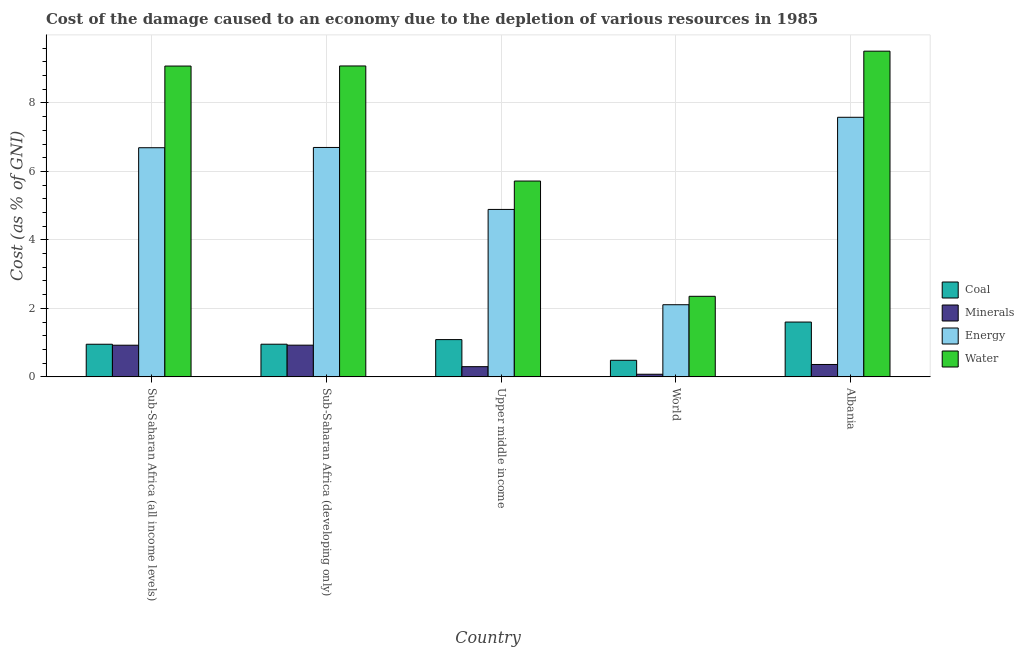What is the label of the 5th group of bars from the left?
Make the answer very short. Albania. In how many cases, is the number of bars for a given country not equal to the number of legend labels?
Ensure brevity in your answer.  0. What is the cost of damage due to depletion of coal in Albania?
Give a very brief answer. 1.6. Across all countries, what is the maximum cost of damage due to depletion of water?
Offer a terse response. 9.51. Across all countries, what is the minimum cost of damage due to depletion of energy?
Provide a succinct answer. 2.11. In which country was the cost of damage due to depletion of water maximum?
Your response must be concise. Albania. What is the total cost of damage due to depletion of energy in the graph?
Provide a succinct answer. 27.97. What is the difference between the cost of damage due to depletion of coal in Sub-Saharan Africa (all income levels) and that in Sub-Saharan Africa (developing only)?
Offer a terse response. -0. What is the difference between the cost of damage due to depletion of coal in Sub-Saharan Africa (developing only) and the cost of damage due to depletion of energy in World?
Provide a succinct answer. -1.15. What is the average cost of damage due to depletion of coal per country?
Provide a short and direct response. 1.02. What is the difference between the cost of damage due to depletion of coal and cost of damage due to depletion of minerals in Sub-Saharan Africa (developing only)?
Your answer should be very brief. 0.03. What is the ratio of the cost of damage due to depletion of coal in Sub-Saharan Africa (all income levels) to that in World?
Offer a very short reply. 1.97. Is the difference between the cost of damage due to depletion of energy in Sub-Saharan Africa (developing only) and Upper middle income greater than the difference between the cost of damage due to depletion of minerals in Sub-Saharan Africa (developing only) and Upper middle income?
Your answer should be compact. Yes. What is the difference between the highest and the second highest cost of damage due to depletion of energy?
Provide a succinct answer. 0.88. What is the difference between the highest and the lowest cost of damage due to depletion of water?
Provide a succinct answer. 7.16. Is the sum of the cost of damage due to depletion of water in Albania and Sub-Saharan Africa (developing only) greater than the maximum cost of damage due to depletion of energy across all countries?
Ensure brevity in your answer.  Yes. Is it the case that in every country, the sum of the cost of damage due to depletion of coal and cost of damage due to depletion of water is greater than the sum of cost of damage due to depletion of energy and cost of damage due to depletion of minerals?
Ensure brevity in your answer.  Yes. What does the 3rd bar from the left in Upper middle income represents?
Keep it short and to the point. Energy. What does the 3rd bar from the right in Albania represents?
Offer a terse response. Minerals. Are all the bars in the graph horizontal?
Provide a short and direct response. No. How many countries are there in the graph?
Ensure brevity in your answer.  5. Does the graph contain any zero values?
Offer a very short reply. No. How many legend labels are there?
Make the answer very short. 4. How are the legend labels stacked?
Provide a short and direct response. Vertical. What is the title of the graph?
Your answer should be very brief. Cost of the damage caused to an economy due to the depletion of various resources in 1985 . Does "Water" appear as one of the legend labels in the graph?
Provide a short and direct response. Yes. What is the label or title of the Y-axis?
Give a very brief answer. Cost (as % of GNI). What is the Cost (as % of GNI) in Coal in Sub-Saharan Africa (all income levels)?
Keep it short and to the point. 0.95. What is the Cost (as % of GNI) in Minerals in Sub-Saharan Africa (all income levels)?
Offer a very short reply. 0.92. What is the Cost (as % of GNI) in Energy in Sub-Saharan Africa (all income levels)?
Make the answer very short. 6.69. What is the Cost (as % of GNI) in Water in Sub-Saharan Africa (all income levels)?
Make the answer very short. 9.08. What is the Cost (as % of GNI) in Coal in Sub-Saharan Africa (developing only)?
Provide a short and direct response. 0.95. What is the Cost (as % of GNI) in Minerals in Sub-Saharan Africa (developing only)?
Provide a succinct answer. 0.93. What is the Cost (as % of GNI) of Energy in Sub-Saharan Africa (developing only)?
Make the answer very short. 6.7. What is the Cost (as % of GNI) in Water in Sub-Saharan Africa (developing only)?
Provide a short and direct response. 9.08. What is the Cost (as % of GNI) of Coal in Upper middle income?
Your answer should be very brief. 1.09. What is the Cost (as % of GNI) of Minerals in Upper middle income?
Give a very brief answer. 0.3. What is the Cost (as % of GNI) of Energy in Upper middle income?
Keep it short and to the point. 4.89. What is the Cost (as % of GNI) in Water in Upper middle income?
Provide a succinct answer. 5.72. What is the Cost (as % of GNI) in Coal in World?
Provide a succinct answer. 0.48. What is the Cost (as % of GNI) of Minerals in World?
Make the answer very short. 0.08. What is the Cost (as % of GNI) in Energy in World?
Offer a very short reply. 2.11. What is the Cost (as % of GNI) of Water in World?
Make the answer very short. 2.35. What is the Cost (as % of GNI) in Coal in Albania?
Keep it short and to the point. 1.6. What is the Cost (as % of GNI) of Minerals in Albania?
Offer a very short reply. 0.36. What is the Cost (as % of GNI) in Energy in Albania?
Your answer should be very brief. 7.58. What is the Cost (as % of GNI) of Water in Albania?
Your answer should be very brief. 9.51. Across all countries, what is the maximum Cost (as % of GNI) in Coal?
Give a very brief answer. 1.6. Across all countries, what is the maximum Cost (as % of GNI) of Minerals?
Offer a very short reply. 0.93. Across all countries, what is the maximum Cost (as % of GNI) of Energy?
Provide a short and direct response. 7.58. Across all countries, what is the maximum Cost (as % of GNI) of Water?
Give a very brief answer. 9.51. Across all countries, what is the minimum Cost (as % of GNI) of Coal?
Give a very brief answer. 0.48. Across all countries, what is the minimum Cost (as % of GNI) of Minerals?
Your answer should be very brief. 0.08. Across all countries, what is the minimum Cost (as % of GNI) of Energy?
Keep it short and to the point. 2.11. Across all countries, what is the minimum Cost (as % of GNI) in Water?
Keep it short and to the point. 2.35. What is the total Cost (as % of GNI) of Coal in the graph?
Your answer should be compact. 5.08. What is the total Cost (as % of GNI) of Minerals in the graph?
Ensure brevity in your answer.  2.59. What is the total Cost (as % of GNI) of Energy in the graph?
Give a very brief answer. 27.97. What is the total Cost (as % of GNI) in Water in the graph?
Offer a very short reply. 35.74. What is the difference between the Cost (as % of GNI) in Coal in Sub-Saharan Africa (all income levels) and that in Sub-Saharan Africa (developing only)?
Offer a terse response. -0. What is the difference between the Cost (as % of GNI) of Minerals in Sub-Saharan Africa (all income levels) and that in Sub-Saharan Africa (developing only)?
Offer a very short reply. -0. What is the difference between the Cost (as % of GNI) in Energy in Sub-Saharan Africa (all income levels) and that in Sub-Saharan Africa (developing only)?
Provide a succinct answer. -0.01. What is the difference between the Cost (as % of GNI) of Water in Sub-Saharan Africa (all income levels) and that in Sub-Saharan Africa (developing only)?
Your response must be concise. -0. What is the difference between the Cost (as % of GNI) of Coal in Sub-Saharan Africa (all income levels) and that in Upper middle income?
Ensure brevity in your answer.  -0.14. What is the difference between the Cost (as % of GNI) of Minerals in Sub-Saharan Africa (all income levels) and that in Upper middle income?
Give a very brief answer. 0.63. What is the difference between the Cost (as % of GNI) of Energy in Sub-Saharan Africa (all income levels) and that in Upper middle income?
Offer a very short reply. 1.8. What is the difference between the Cost (as % of GNI) in Water in Sub-Saharan Africa (all income levels) and that in Upper middle income?
Give a very brief answer. 3.36. What is the difference between the Cost (as % of GNI) of Coal in Sub-Saharan Africa (all income levels) and that in World?
Your response must be concise. 0.47. What is the difference between the Cost (as % of GNI) of Minerals in Sub-Saharan Africa (all income levels) and that in World?
Ensure brevity in your answer.  0.85. What is the difference between the Cost (as % of GNI) in Energy in Sub-Saharan Africa (all income levels) and that in World?
Your answer should be compact. 4.59. What is the difference between the Cost (as % of GNI) of Water in Sub-Saharan Africa (all income levels) and that in World?
Make the answer very short. 6.72. What is the difference between the Cost (as % of GNI) of Coal in Sub-Saharan Africa (all income levels) and that in Albania?
Your answer should be compact. -0.65. What is the difference between the Cost (as % of GNI) of Minerals in Sub-Saharan Africa (all income levels) and that in Albania?
Your response must be concise. 0.56. What is the difference between the Cost (as % of GNI) of Energy in Sub-Saharan Africa (all income levels) and that in Albania?
Your response must be concise. -0.89. What is the difference between the Cost (as % of GNI) of Water in Sub-Saharan Africa (all income levels) and that in Albania?
Your answer should be compact. -0.43. What is the difference between the Cost (as % of GNI) in Coal in Sub-Saharan Africa (developing only) and that in Upper middle income?
Provide a short and direct response. -0.13. What is the difference between the Cost (as % of GNI) of Minerals in Sub-Saharan Africa (developing only) and that in Upper middle income?
Your answer should be compact. 0.63. What is the difference between the Cost (as % of GNI) of Energy in Sub-Saharan Africa (developing only) and that in Upper middle income?
Ensure brevity in your answer.  1.81. What is the difference between the Cost (as % of GNI) of Water in Sub-Saharan Africa (developing only) and that in Upper middle income?
Make the answer very short. 3.36. What is the difference between the Cost (as % of GNI) in Coal in Sub-Saharan Africa (developing only) and that in World?
Your answer should be compact. 0.47. What is the difference between the Cost (as % of GNI) of Minerals in Sub-Saharan Africa (developing only) and that in World?
Offer a very short reply. 0.85. What is the difference between the Cost (as % of GNI) of Energy in Sub-Saharan Africa (developing only) and that in World?
Your response must be concise. 4.59. What is the difference between the Cost (as % of GNI) of Water in Sub-Saharan Africa (developing only) and that in World?
Provide a succinct answer. 6.73. What is the difference between the Cost (as % of GNI) in Coal in Sub-Saharan Africa (developing only) and that in Albania?
Give a very brief answer. -0.65. What is the difference between the Cost (as % of GNI) in Minerals in Sub-Saharan Africa (developing only) and that in Albania?
Your answer should be compact. 0.56. What is the difference between the Cost (as % of GNI) of Energy in Sub-Saharan Africa (developing only) and that in Albania?
Offer a very short reply. -0.88. What is the difference between the Cost (as % of GNI) of Water in Sub-Saharan Africa (developing only) and that in Albania?
Offer a terse response. -0.43. What is the difference between the Cost (as % of GNI) of Coal in Upper middle income and that in World?
Offer a very short reply. 0.6. What is the difference between the Cost (as % of GNI) of Minerals in Upper middle income and that in World?
Give a very brief answer. 0.22. What is the difference between the Cost (as % of GNI) in Energy in Upper middle income and that in World?
Make the answer very short. 2.78. What is the difference between the Cost (as % of GNI) of Water in Upper middle income and that in World?
Provide a short and direct response. 3.37. What is the difference between the Cost (as % of GNI) in Coal in Upper middle income and that in Albania?
Offer a very short reply. -0.51. What is the difference between the Cost (as % of GNI) in Minerals in Upper middle income and that in Albania?
Offer a very short reply. -0.06. What is the difference between the Cost (as % of GNI) of Energy in Upper middle income and that in Albania?
Offer a terse response. -2.69. What is the difference between the Cost (as % of GNI) in Water in Upper middle income and that in Albania?
Make the answer very short. -3.79. What is the difference between the Cost (as % of GNI) of Coal in World and that in Albania?
Ensure brevity in your answer.  -1.12. What is the difference between the Cost (as % of GNI) in Minerals in World and that in Albania?
Offer a very short reply. -0.29. What is the difference between the Cost (as % of GNI) in Energy in World and that in Albania?
Provide a succinct answer. -5.47. What is the difference between the Cost (as % of GNI) in Water in World and that in Albania?
Give a very brief answer. -7.16. What is the difference between the Cost (as % of GNI) in Coal in Sub-Saharan Africa (all income levels) and the Cost (as % of GNI) in Minerals in Sub-Saharan Africa (developing only)?
Give a very brief answer. 0.03. What is the difference between the Cost (as % of GNI) of Coal in Sub-Saharan Africa (all income levels) and the Cost (as % of GNI) of Energy in Sub-Saharan Africa (developing only)?
Offer a very short reply. -5.75. What is the difference between the Cost (as % of GNI) in Coal in Sub-Saharan Africa (all income levels) and the Cost (as % of GNI) in Water in Sub-Saharan Africa (developing only)?
Ensure brevity in your answer.  -8.13. What is the difference between the Cost (as % of GNI) of Minerals in Sub-Saharan Africa (all income levels) and the Cost (as % of GNI) of Energy in Sub-Saharan Africa (developing only)?
Keep it short and to the point. -5.77. What is the difference between the Cost (as % of GNI) in Minerals in Sub-Saharan Africa (all income levels) and the Cost (as % of GNI) in Water in Sub-Saharan Africa (developing only)?
Provide a short and direct response. -8.16. What is the difference between the Cost (as % of GNI) of Energy in Sub-Saharan Africa (all income levels) and the Cost (as % of GNI) of Water in Sub-Saharan Africa (developing only)?
Your answer should be compact. -2.39. What is the difference between the Cost (as % of GNI) of Coal in Sub-Saharan Africa (all income levels) and the Cost (as % of GNI) of Minerals in Upper middle income?
Give a very brief answer. 0.65. What is the difference between the Cost (as % of GNI) in Coal in Sub-Saharan Africa (all income levels) and the Cost (as % of GNI) in Energy in Upper middle income?
Make the answer very short. -3.94. What is the difference between the Cost (as % of GNI) in Coal in Sub-Saharan Africa (all income levels) and the Cost (as % of GNI) in Water in Upper middle income?
Provide a succinct answer. -4.77. What is the difference between the Cost (as % of GNI) in Minerals in Sub-Saharan Africa (all income levels) and the Cost (as % of GNI) in Energy in Upper middle income?
Your answer should be compact. -3.97. What is the difference between the Cost (as % of GNI) in Minerals in Sub-Saharan Africa (all income levels) and the Cost (as % of GNI) in Water in Upper middle income?
Offer a terse response. -4.79. What is the difference between the Cost (as % of GNI) in Energy in Sub-Saharan Africa (all income levels) and the Cost (as % of GNI) in Water in Upper middle income?
Provide a short and direct response. 0.97. What is the difference between the Cost (as % of GNI) of Coal in Sub-Saharan Africa (all income levels) and the Cost (as % of GNI) of Minerals in World?
Make the answer very short. 0.88. What is the difference between the Cost (as % of GNI) of Coal in Sub-Saharan Africa (all income levels) and the Cost (as % of GNI) of Energy in World?
Make the answer very short. -1.15. What is the difference between the Cost (as % of GNI) of Coal in Sub-Saharan Africa (all income levels) and the Cost (as % of GNI) of Water in World?
Provide a succinct answer. -1.4. What is the difference between the Cost (as % of GNI) in Minerals in Sub-Saharan Africa (all income levels) and the Cost (as % of GNI) in Energy in World?
Your response must be concise. -1.18. What is the difference between the Cost (as % of GNI) in Minerals in Sub-Saharan Africa (all income levels) and the Cost (as % of GNI) in Water in World?
Give a very brief answer. -1.43. What is the difference between the Cost (as % of GNI) in Energy in Sub-Saharan Africa (all income levels) and the Cost (as % of GNI) in Water in World?
Give a very brief answer. 4.34. What is the difference between the Cost (as % of GNI) in Coal in Sub-Saharan Africa (all income levels) and the Cost (as % of GNI) in Minerals in Albania?
Provide a succinct answer. 0.59. What is the difference between the Cost (as % of GNI) in Coal in Sub-Saharan Africa (all income levels) and the Cost (as % of GNI) in Energy in Albania?
Offer a very short reply. -6.63. What is the difference between the Cost (as % of GNI) of Coal in Sub-Saharan Africa (all income levels) and the Cost (as % of GNI) of Water in Albania?
Offer a very short reply. -8.56. What is the difference between the Cost (as % of GNI) in Minerals in Sub-Saharan Africa (all income levels) and the Cost (as % of GNI) in Energy in Albania?
Your answer should be compact. -6.66. What is the difference between the Cost (as % of GNI) of Minerals in Sub-Saharan Africa (all income levels) and the Cost (as % of GNI) of Water in Albania?
Keep it short and to the point. -8.59. What is the difference between the Cost (as % of GNI) in Energy in Sub-Saharan Africa (all income levels) and the Cost (as % of GNI) in Water in Albania?
Make the answer very short. -2.82. What is the difference between the Cost (as % of GNI) in Coal in Sub-Saharan Africa (developing only) and the Cost (as % of GNI) in Minerals in Upper middle income?
Keep it short and to the point. 0.66. What is the difference between the Cost (as % of GNI) in Coal in Sub-Saharan Africa (developing only) and the Cost (as % of GNI) in Energy in Upper middle income?
Make the answer very short. -3.94. What is the difference between the Cost (as % of GNI) of Coal in Sub-Saharan Africa (developing only) and the Cost (as % of GNI) of Water in Upper middle income?
Keep it short and to the point. -4.77. What is the difference between the Cost (as % of GNI) of Minerals in Sub-Saharan Africa (developing only) and the Cost (as % of GNI) of Energy in Upper middle income?
Your answer should be compact. -3.96. What is the difference between the Cost (as % of GNI) of Minerals in Sub-Saharan Africa (developing only) and the Cost (as % of GNI) of Water in Upper middle income?
Provide a short and direct response. -4.79. What is the difference between the Cost (as % of GNI) of Energy in Sub-Saharan Africa (developing only) and the Cost (as % of GNI) of Water in Upper middle income?
Your answer should be very brief. 0.98. What is the difference between the Cost (as % of GNI) of Coal in Sub-Saharan Africa (developing only) and the Cost (as % of GNI) of Minerals in World?
Provide a succinct answer. 0.88. What is the difference between the Cost (as % of GNI) of Coal in Sub-Saharan Africa (developing only) and the Cost (as % of GNI) of Energy in World?
Your response must be concise. -1.15. What is the difference between the Cost (as % of GNI) in Coal in Sub-Saharan Africa (developing only) and the Cost (as % of GNI) in Water in World?
Keep it short and to the point. -1.4. What is the difference between the Cost (as % of GNI) of Minerals in Sub-Saharan Africa (developing only) and the Cost (as % of GNI) of Energy in World?
Give a very brief answer. -1.18. What is the difference between the Cost (as % of GNI) in Minerals in Sub-Saharan Africa (developing only) and the Cost (as % of GNI) in Water in World?
Your response must be concise. -1.43. What is the difference between the Cost (as % of GNI) of Energy in Sub-Saharan Africa (developing only) and the Cost (as % of GNI) of Water in World?
Your answer should be compact. 4.35. What is the difference between the Cost (as % of GNI) of Coal in Sub-Saharan Africa (developing only) and the Cost (as % of GNI) of Minerals in Albania?
Make the answer very short. 0.59. What is the difference between the Cost (as % of GNI) of Coal in Sub-Saharan Africa (developing only) and the Cost (as % of GNI) of Energy in Albania?
Provide a succinct answer. -6.63. What is the difference between the Cost (as % of GNI) in Coal in Sub-Saharan Africa (developing only) and the Cost (as % of GNI) in Water in Albania?
Make the answer very short. -8.56. What is the difference between the Cost (as % of GNI) in Minerals in Sub-Saharan Africa (developing only) and the Cost (as % of GNI) in Energy in Albania?
Give a very brief answer. -6.65. What is the difference between the Cost (as % of GNI) of Minerals in Sub-Saharan Africa (developing only) and the Cost (as % of GNI) of Water in Albania?
Your response must be concise. -8.59. What is the difference between the Cost (as % of GNI) in Energy in Sub-Saharan Africa (developing only) and the Cost (as % of GNI) in Water in Albania?
Offer a very short reply. -2.81. What is the difference between the Cost (as % of GNI) in Coal in Upper middle income and the Cost (as % of GNI) in Minerals in World?
Provide a succinct answer. 1.01. What is the difference between the Cost (as % of GNI) of Coal in Upper middle income and the Cost (as % of GNI) of Energy in World?
Offer a terse response. -1.02. What is the difference between the Cost (as % of GNI) of Coal in Upper middle income and the Cost (as % of GNI) of Water in World?
Make the answer very short. -1.26. What is the difference between the Cost (as % of GNI) of Minerals in Upper middle income and the Cost (as % of GNI) of Energy in World?
Provide a short and direct response. -1.81. What is the difference between the Cost (as % of GNI) of Minerals in Upper middle income and the Cost (as % of GNI) of Water in World?
Your answer should be very brief. -2.05. What is the difference between the Cost (as % of GNI) in Energy in Upper middle income and the Cost (as % of GNI) in Water in World?
Provide a short and direct response. 2.54. What is the difference between the Cost (as % of GNI) of Coal in Upper middle income and the Cost (as % of GNI) of Minerals in Albania?
Offer a very short reply. 0.73. What is the difference between the Cost (as % of GNI) of Coal in Upper middle income and the Cost (as % of GNI) of Energy in Albania?
Your answer should be compact. -6.49. What is the difference between the Cost (as % of GNI) of Coal in Upper middle income and the Cost (as % of GNI) of Water in Albania?
Give a very brief answer. -8.42. What is the difference between the Cost (as % of GNI) of Minerals in Upper middle income and the Cost (as % of GNI) of Energy in Albania?
Make the answer very short. -7.28. What is the difference between the Cost (as % of GNI) of Minerals in Upper middle income and the Cost (as % of GNI) of Water in Albania?
Your answer should be compact. -9.21. What is the difference between the Cost (as % of GNI) of Energy in Upper middle income and the Cost (as % of GNI) of Water in Albania?
Provide a short and direct response. -4.62. What is the difference between the Cost (as % of GNI) in Coal in World and the Cost (as % of GNI) in Minerals in Albania?
Make the answer very short. 0.12. What is the difference between the Cost (as % of GNI) of Coal in World and the Cost (as % of GNI) of Energy in Albania?
Ensure brevity in your answer.  -7.1. What is the difference between the Cost (as % of GNI) in Coal in World and the Cost (as % of GNI) in Water in Albania?
Your response must be concise. -9.03. What is the difference between the Cost (as % of GNI) in Minerals in World and the Cost (as % of GNI) in Energy in Albania?
Provide a short and direct response. -7.5. What is the difference between the Cost (as % of GNI) of Minerals in World and the Cost (as % of GNI) of Water in Albania?
Provide a short and direct response. -9.44. What is the difference between the Cost (as % of GNI) in Energy in World and the Cost (as % of GNI) in Water in Albania?
Ensure brevity in your answer.  -7.41. What is the average Cost (as % of GNI) of Coal per country?
Provide a succinct answer. 1.02. What is the average Cost (as % of GNI) of Minerals per country?
Offer a terse response. 0.52. What is the average Cost (as % of GNI) of Energy per country?
Provide a short and direct response. 5.59. What is the average Cost (as % of GNI) in Water per country?
Provide a short and direct response. 7.15. What is the difference between the Cost (as % of GNI) of Coal and Cost (as % of GNI) of Minerals in Sub-Saharan Africa (all income levels)?
Offer a very short reply. 0.03. What is the difference between the Cost (as % of GNI) in Coal and Cost (as % of GNI) in Energy in Sub-Saharan Africa (all income levels)?
Offer a terse response. -5.74. What is the difference between the Cost (as % of GNI) in Coal and Cost (as % of GNI) in Water in Sub-Saharan Africa (all income levels)?
Offer a very short reply. -8.12. What is the difference between the Cost (as % of GNI) of Minerals and Cost (as % of GNI) of Energy in Sub-Saharan Africa (all income levels)?
Make the answer very short. -5.77. What is the difference between the Cost (as % of GNI) in Minerals and Cost (as % of GNI) in Water in Sub-Saharan Africa (all income levels)?
Make the answer very short. -8.15. What is the difference between the Cost (as % of GNI) in Energy and Cost (as % of GNI) in Water in Sub-Saharan Africa (all income levels)?
Offer a terse response. -2.38. What is the difference between the Cost (as % of GNI) in Coal and Cost (as % of GNI) in Minerals in Sub-Saharan Africa (developing only)?
Your response must be concise. 0.03. What is the difference between the Cost (as % of GNI) of Coal and Cost (as % of GNI) of Energy in Sub-Saharan Africa (developing only)?
Your response must be concise. -5.75. What is the difference between the Cost (as % of GNI) in Coal and Cost (as % of GNI) in Water in Sub-Saharan Africa (developing only)?
Provide a succinct answer. -8.13. What is the difference between the Cost (as % of GNI) of Minerals and Cost (as % of GNI) of Energy in Sub-Saharan Africa (developing only)?
Your answer should be very brief. -5.77. What is the difference between the Cost (as % of GNI) in Minerals and Cost (as % of GNI) in Water in Sub-Saharan Africa (developing only)?
Make the answer very short. -8.15. What is the difference between the Cost (as % of GNI) in Energy and Cost (as % of GNI) in Water in Sub-Saharan Africa (developing only)?
Your response must be concise. -2.38. What is the difference between the Cost (as % of GNI) in Coal and Cost (as % of GNI) in Minerals in Upper middle income?
Keep it short and to the point. 0.79. What is the difference between the Cost (as % of GNI) of Coal and Cost (as % of GNI) of Energy in Upper middle income?
Your answer should be compact. -3.8. What is the difference between the Cost (as % of GNI) in Coal and Cost (as % of GNI) in Water in Upper middle income?
Keep it short and to the point. -4.63. What is the difference between the Cost (as % of GNI) in Minerals and Cost (as % of GNI) in Energy in Upper middle income?
Provide a succinct answer. -4.59. What is the difference between the Cost (as % of GNI) in Minerals and Cost (as % of GNI) in Water in Upper middle income?
Ensure brevity in your answer.  -5.42. What is the difference between the Cost (as % of GNI) in Energy and Cost (as % of GNI) in Water in Upper middle income?
Offer a very short reply. -0.83. What is the difference between the Cost (as % of GNI) of Coal and Cost (as % of GNI) of Minerals in World?
Your response must be concise. 0.41. What is the difference between the Cost (as % of GNI) of Coal and Cost (as % of GNI) of Energy in World?
Offer a terse response. -1.62. What is the difference between the Cost (as % of GNI) of Coal and Cost (as % of GNI) of Water in World?
Give a very brief answer. -1.87. What is the difference between the Cost (as % of GNI) in Minerals and Cost (as % of GNI) in Energy in World?
Offer a terse response. -2.03. What is the difference between the Cost (as % of GNI) in Minerals and Cost (as % of GNI) in Water in World?
Ensure brevity in your answer.  -2.28. What is the difference between the Cost (as % of GNI) in Energy and Cost (as % of GNI) in Water in World?
Offer a terse response. -0.25. What is the difference between the Cost (as % of GNI) of Coal and Cost (as % of GNI) of Minerals in Albania?
Your response must be concise. 1.24. What is the difference between the Cost (as % of GNI) in Coal and Cost (as % of GNI) in Energy in Albania?
Ensure brevity in your answer.  -5.98. What is the difference between the Cost (as % of GNI) in Coal and Cost (as % of GNI) in Water in Albania?
Your response must be concise. -7.91. What is the difference between the Cost (as % of GNI) of Minerals and Cost (as % of GNI) of Energy in Albania?
Your response must be concise. -7.22. What is the difference between the Cost (as % of GNI) in Minerals and Cost (as % of GNI) in Water in Albania?
Give a very brief answer. -9.15. What is the difference between the Cost (as % of GNI) of Energy and Cost (as % of GNI) of Water in Albania?
Ensure brevity in your answer.  -1.93. What is the ratio of the Cost (as % of GNI) of Water in Sub-Saharan Africa (all income levels) to that in Sub-Saharan Africa (developing only)?
Offer a very short reply. 1. What is the ratio of the Cost (as % of GNI) in Coal in Sub-Saharan Africa (all income levels) to that in Upper middle income?
Give a very brief answer. 0.88. What is the ratio of the Cost (as % of GNI) in Minerals in Sub-Saharan Africa (all income levels) to that in Upper middle income?
Ensure brevity in your answer.  3.1. What is the ratio of the Cost (as % of GNI) of Energy in Sub-Saharan Africa (all income levels) to that in Upper middle income?
Offer a terse response. 1.37. What is the ratio of the Cost (as % of GNI) in Water in Sub-Saharan Africa (all income levels) to that in Upper middle income?
Keep it short and to the point. 1.59. What is the ratio of the Cost (as % of GNI) of Coal in Sub-Saharan Africa (all income levels) to that in World?
Ensure brevity in your answer.  1.97. What is the ratio of the Cost (as % of GNI) in Minerals in Sub-Saharan Africa (all income levels) to that in World?
Your answer should be very brief. 12.06. What is the ratio of the Cost (as % of GNI) of Energy in Sub-Saharan Africa (all income levels) to that in World?
Your response must be concise. 3.18. What is the ratio of the Cost (as % of GNI) of Water in Sub-Saharan Africa (all income levels) to that in World?
Your response must be concise. 3.86. What is the ratio of the Cost (as % of GNI) in Coal in Sub-Saharan Africa (all income levels) to that in Albania?
Your response must be concise. 0.6. What is the ratio of the Cost (as % of GNI) of Minerals in Sub-Saharan Africa (all income levels) to that in Albania?
Offer a very short reply. 2.55. What is the ratio of the Cost (as % of GNI) of Energy in Sub-Saharan Africa (all income levels) to that in Albania?
Give a very brief answer. 0.88. What is the ratio of the Cost (as % of GNI) in Water in Sub-Saharan Africa (all income levels) to that in Albania?
Give a very brief answer. 0.95. What is the ratio of the Cost (as % of GNI) in Coal in Sub-Saharan Africa (developing only) to that in Upper middle income?
Make the answer very short. 0.88. What is the ratio of the Cost (as % of GNI) of Minerals in Sub-Saharan Africa (developing only) to that in Upper middle income?
Offer a very short reply. 3.11. What is the ratio of the Cost (as % of GNI) in Energy in Sub-Saharan Africa (developing only) to that in Upper middle income?
Provide a short and direct response. 1.37. What is the ratio of the Cost (as % of GNI) of Water in Sub-Saharan Africa (developing only) to that in Upper middle income?
Your answer should be very brief. 1.59. What is the ratio of the Cost (as % of GNI) in Coal in Sub-Saharan Africa (developing only) to that in World?
Provide a short and direct response. 1.97. What is the ratio of the Cost (as % of GNI) in Minerals in Sub-Saharan Africa (developing only) to that in World?
Ensure brevity in your answer.  12.07. What is the ratio of the Cost (as % of GNI) of Energy in Sub-Saharan Africa (developing only) to that in World?
Provide a succinct answer. 3.18. What is the ratio of the Cost (as % of GNI) of Water in Sub-Saharan Africa (developing only) to that in World?
Ensure brevity in your answer.  3.86. What is the ratio of the Cost (as % of GNI) of Coal in Sub-Saharan Africa (developing only) to that in Albania?
Keep it short and to the point. 0.6. What is the ratio of the Cost (as % of GNI) in Minerals in Sub-Saharan Africa (developing only) to that in Albania?
Your answer should be very brief. 2.56. What is the ratio of the Cost (as % of GNI) in Energy in Sub-Saharan Africa (developing only) to that in Albania?
Provide a succinct answer. 0.88. What is the ratio of the Cost (as % of GNI) of Water in Sub-Saharan Africa (developing only) to that in Albania?
Provide a short and direct response. 0.95. What is the ratio of the Cost (as % of GNI) in Coal in Upper middle income to that in World?
Your answer should be compact. 2.25. What is the ratio of the Cost (as % of GNI) in Minerals in Upper middle income to that in World?
Make the answer very short. 3.89. What is the ratio of the Cost (as % of GNI) of Energy in Upper middle income to that in World?
Give a very brief answer. 2.32. What is the ratio of the Cost (as % of GNI) of Water in Upper middle income to that in World?
Offer a very short reply. 2.43. What is the ratio of the Cost (as % of GNI) in Coal in Upper middle income to that in Albania?
Provide a short and direct response. 0.68. What is the ratio of the Cost (as % of GNI) of Minerals in Upper middle income to that in Albania?
Offer a terse response. 0.82. What is the ratio of the Cost (as % of GNI) of Energy in Upper middle income to that in Albania?
Provide a short and direct response. 0.65. What is the ratio of the Cost (as % of GNI) of Water in Upper middle income to that in Albania?
Keep it short and to the point. 0.6. What is the ratio of the Cost (as % of GNI) of Coal in World to that in Albania?
Ensure brevity in your answer.  0.3. What is the ratio of the Cost (as % of GNI) of Minerals in World to that in Albania?
Offer a very short reply. 0.21. What is the ratio of the Cost (as % of GNI) in Energy in World to that in Albania?
Provide a succinct answer. 0.28. What is the ratio of the Cost (as % of GNI) of Water in World to that in Albania?
Give a very brief answer. 0.25. What is the difference between the highest and the second highest Cost (as % of GNI) of Coal?
Provide a short and direct response. 0.51. What is the difference between the highest and the second highest Cost (as % of GNI) of Energy?
Ensure brevity in your answer.  0.88. What is the difference between the highest and the second highest Cost (as % of GNI) in Water?
Your response must be concise. 0.43. What is the difference between the highest and the lowest Cost (as % of GNI) of Coal?
Provide a short and direct response. 1.12. What is the difference between the highest and the lowest Cost (as % of GNI) in Minerals?
Provide a short and direct response. 0.85. What is the difference between the highest and the lowest Cost (as % of GNI) of Energy?
Provide a succinct answer. 5.47. What is the difference between the highest and the lowest Cost (as % of GNI) in Water?
Offer a terse response. 7.16. 